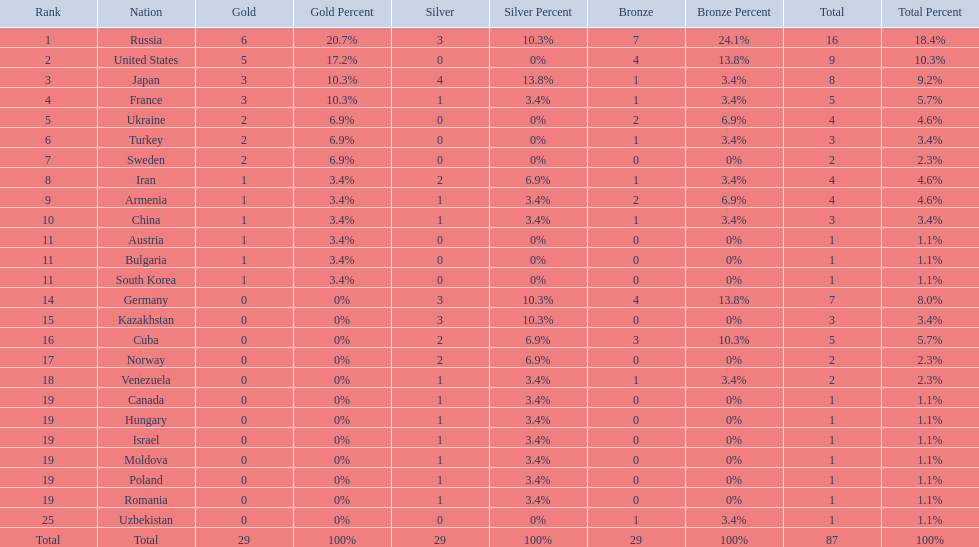Which nation was not in the top 10 iran or germany? Germany. 